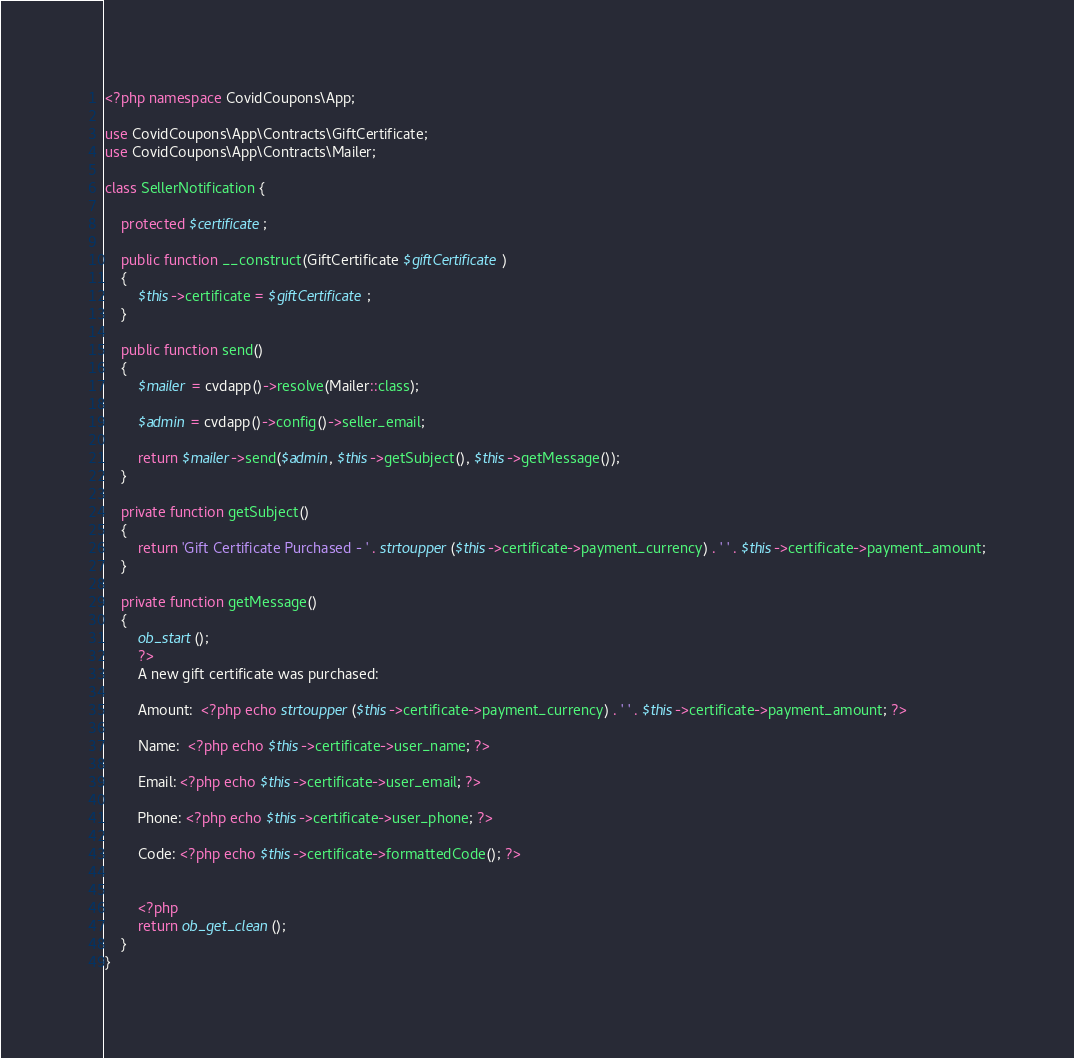<code> <loc_0><loc_0><loc_500><loc_500><_PHP_><?php namespace CovidCoupons\App;

use CovidCoupons\App\Contracts\GiftCertificate;
use CovidCoupons\App\Contracts\Mailer;

class SellerNotification {

    protected $certificate;

    public function __construct(GiftCertificate $giftCertificate)
    {
        $this->certificate = $giftCertificate;
    }

    public function send()
    {
        $mailer = cvdapp()->resolve(Mailer::class);

        $admin = cvdapp()->config()->seller_email;
        
        return $mailer->send($admin, $this->getSubject(), $this->getMessage());
    }

    private function getSubject()
    {
        return 'Gift Certificate Purchased - ' . strtoupper($this->certificate->payment_currency) . ' ' . $this->certificate->payment_amount;
    }

    private function getMessage()
    {
        ob_start();
        ?>
        A new gift certificate was purchased:

        Amount:  <?php echo strtoupper($this->certificate->payment_currency) . ' ' . $this->certificate->payment_amount; ?>

        Name:  <?php echo $this->certificate->user_name; ?>

        Email: <?php echo $this->certificate->user_email; ?>

        Phone: <?php echo $this->certificate->user_phone; ?>

        Code: <?php echo $this->certificate->formattedCode(); ?>


        <?php
        return ob_get_clean();
    }
}</code> 